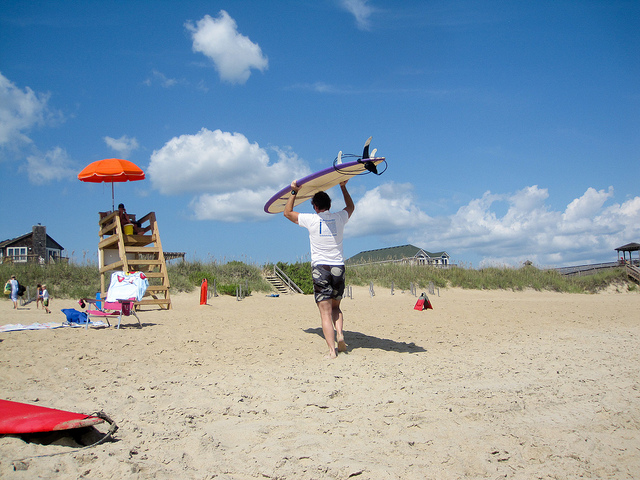Can you describe the weather in the image? The weather looks to be quite favorable for a day at the beach. The sky is predominantly clear with just a few light clouds, indicating a sunny and pleasant day. This is ideal for beachgoers looking to surf, sunbathe, or simply enjoy the beach atmosphere. 